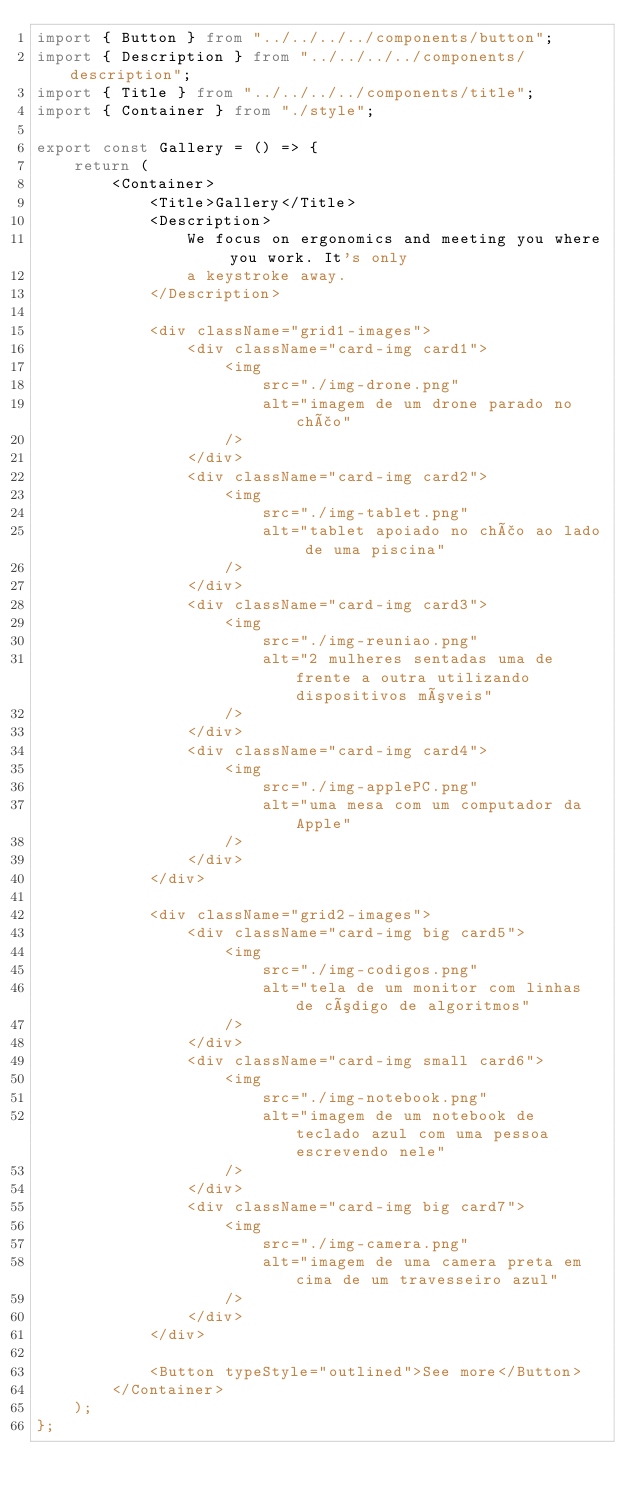<code> <loc_0><loc_0><loc_500><loc_500><_TypeScript_>import { Button } from "../../../../components/button";
import { Description } from "../../../../components/description";
import { Title } from "../../../../components/title";
import { Container } from "./style";

export const Gallery = () => {
    return (
        <Container>
            <Title>Gallery</Title>
            <Description>
                We focus on ergonomics and meeting you where you work. It's only
                a keystroke away.
            </Description>

            <div className="grid1-images">
                <div className="card-img card1">
                    <img
                        src="./img-drone.png"
                        alt="imagem de um drone parado no chão"
                    />
                </div>
                <div className="card-img card2">
                    <img
                        src="./img-tablet.png"
                        alt="tablet apoiado no chão ao lado de uma piscina"
                    />
                </div>
                <div className="card-img card3">
                    <img
                        src="./img-reuniao.png"
                        alt="2 mulheres sentadas uma de frente a outra utilizando dispositivos móveis"
                    />
                </div>
                <div className="card-img card4">
                    <img
                        src="./img-applePC.png"
                        alt="uma mesa com um computador da Apple"
                    />
                </div>
            </div>

            <div className="grid2-images">
                <div className="card-img big card5">
                    <img
                        src="./img-codigos.png"
                        alt="tela de um monitor com linhas de código de algoritmos"
                    />
                </div>
                <div className="card-img small card6">
                    <img
                        src="./img-notebook.png"
                        alt="imagem de um notebook de teclado azul com uma pessoa escrevendo nele"
                    />
                </div>
                <div className="card-img big card7">
                    <img
                        src="./img-camera.png"
                        alt="imagem de uma camera preta em cima de um travesseiro azul"
                    />
                </div>
            </div>

            <Button typeStyle="outlined">See more</Button>
        </Container>
    );
};
</code> 